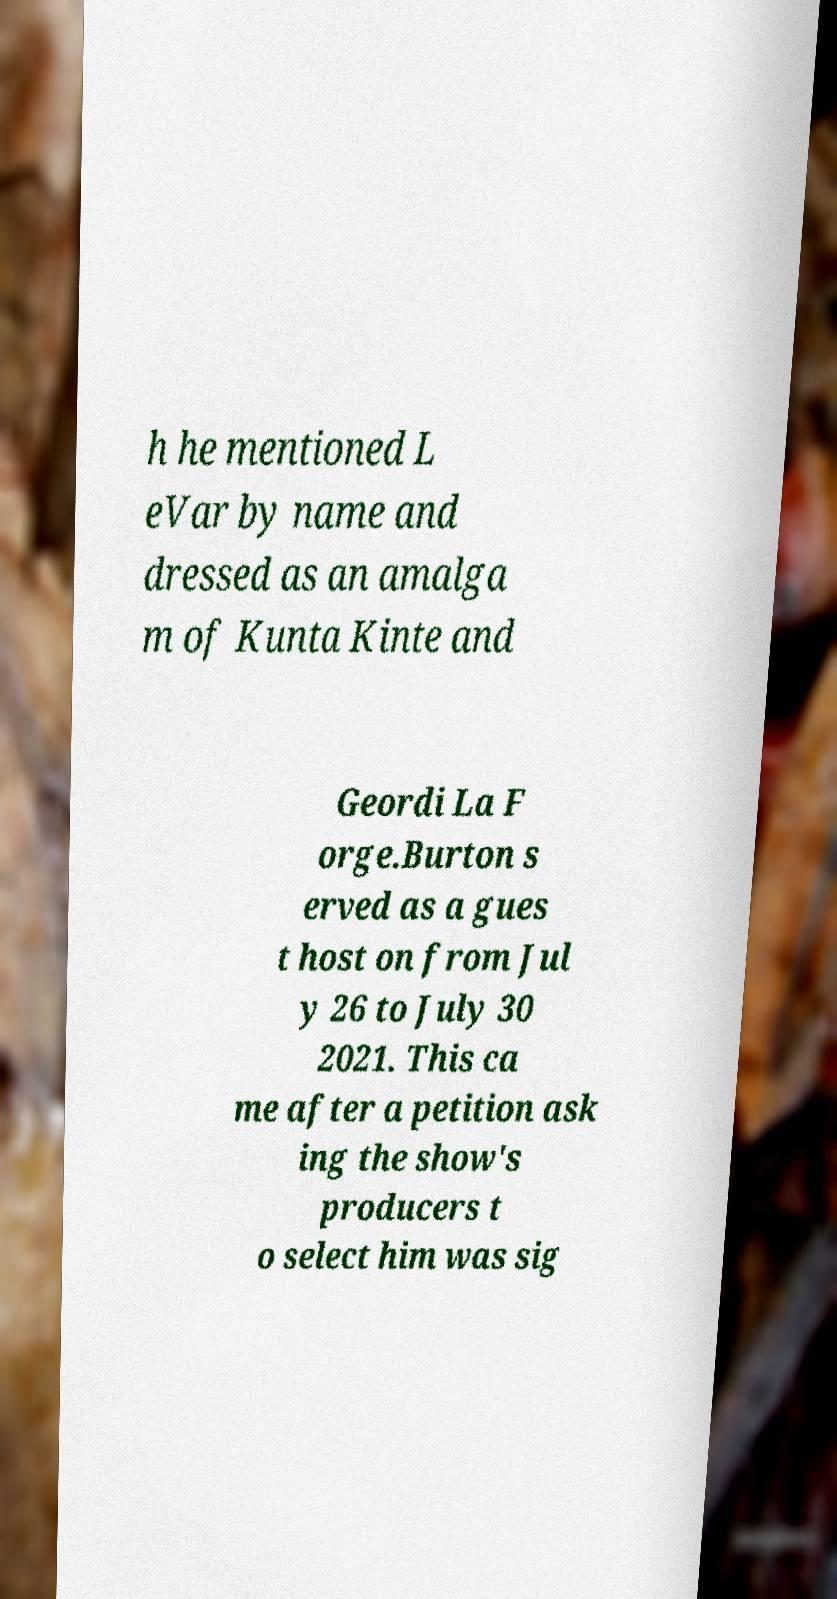Please identify and transcribe the text found in this image. h he mentioned L eVar by name and dressed as an amalga m of Kunta Kinte and Geordi La F orge.Burton s erved as a gues t host on from Jul y 26 to July 30 2021. This ca me after a petition ask ing the show's producers t o select him was sig 